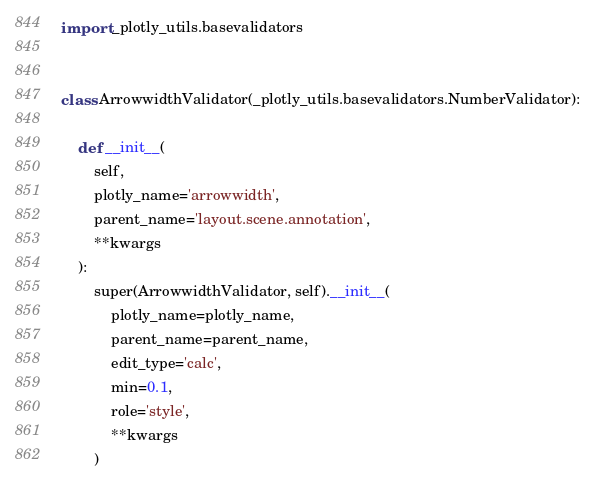Convert code to text. <code><loc_0><loc_0><loc_500><loc_500><_Python_>import _plotly_utils.basevalidators


class ArrowwidthValidator(_plotly_utils.basevalidators.NumberValidator):

    def __init__(
        self,
        plotly_name='arrowwidth',
        parent_name='layout.scene.annotation',
        **kwargs
    ):
        super(ArrowwidthValidator, self).__init__(
            plotly_name=plotly_name,
            parent_name=parent_name,
            edit_type='calc',
            min=0.1,
            role='style',
            **kwargs
        )
</code> 